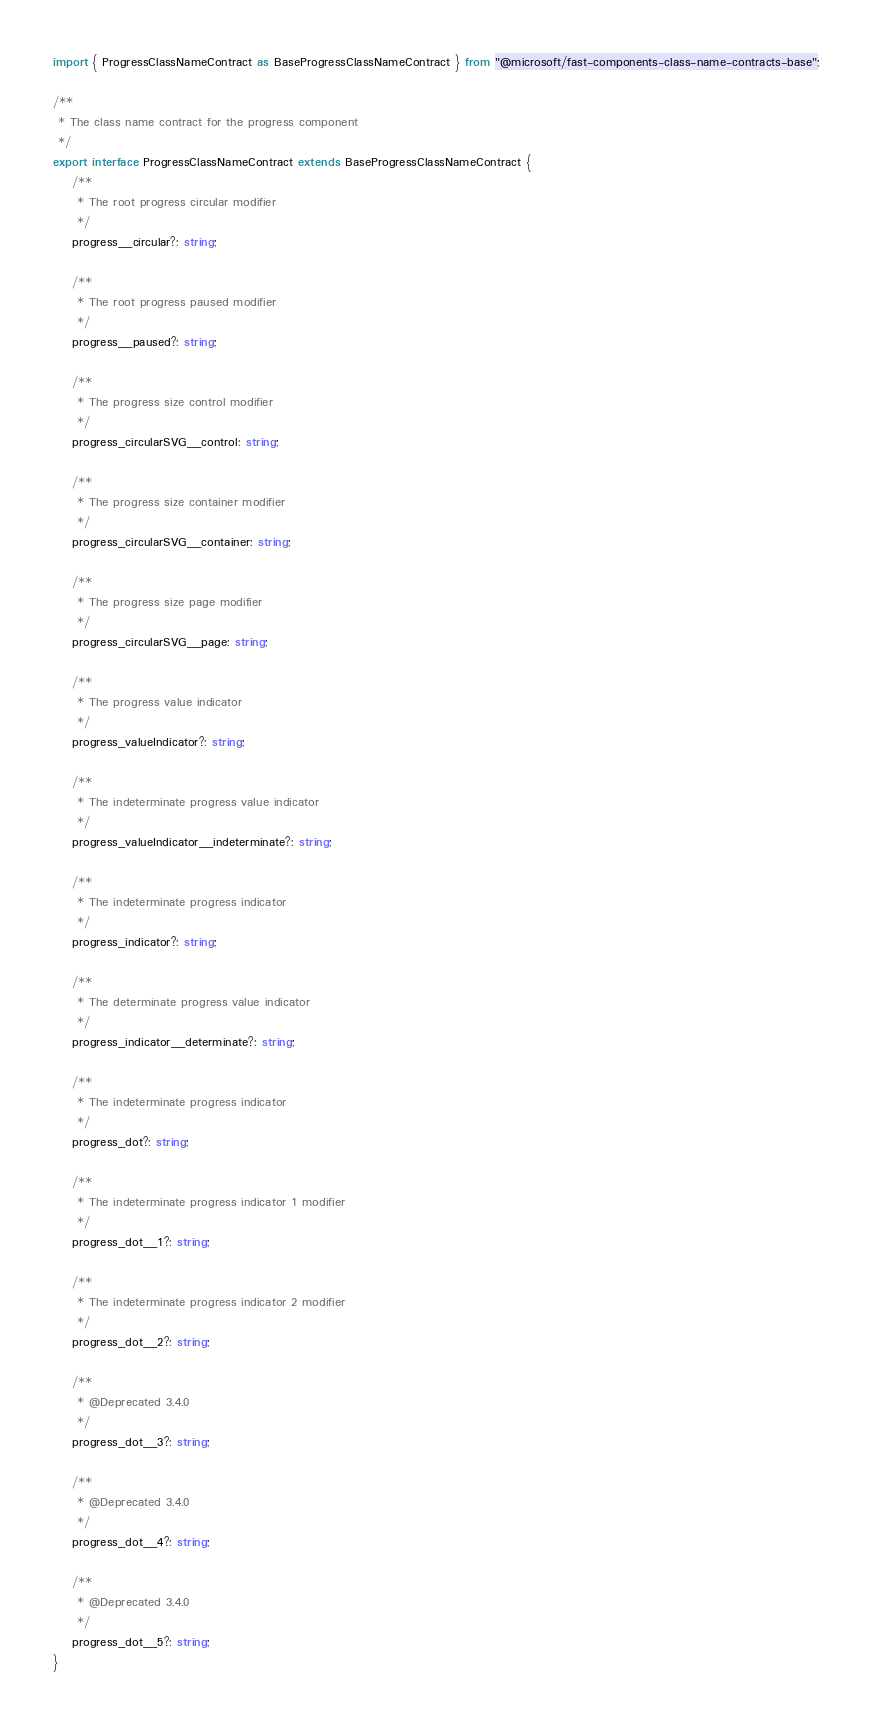<code> <loc_0><loc_0><loc_500><loc_500><_TypeScript_>import { ProgressClassNameContract as BaseProgressClassNameContract } from "@microsoft/fast-components-class-name-contracts-base";

/**
 * The class name contract for the progress component
 */
export interface ProgressClassNameContract extends BaseProgressClassNameContract {
    /**
     * The root progress circular modifier
     */
    progress__circular?: string;

    /**
     * The root progress paused modifier
     */
    progress__paused?: string;

    /**
     * The progress size control modifier
     */
    progress_circularSVG__control: string;

    /**
     * The progress size container modifier
     */
    progress_circularSVG__container: string;

    /**
     * The progress size page modifier
     */
    progress_circularSVG__page: string;

    /**
     * The progress value indicator
     */
    progress_valueIndicator?: string;

    /**
     * The indeterminate progress value indicator
     */
    progress_valueIndicator__indeterminate?: string;

    /**
     * The indeterminate progress indicator
     */
    progress_indicator?: string;

    /**
     * The determinate progress value indicator
     */
    progress_indicator__determinate?: string;

    /**
     * The indeterminate progress indicator
     */
    progress_dot?: string;

    /**
     * The indeterminate progress indicator 1 modifier
     */
    progress_dot__1?: string;

    /**
     * The indeterminate progress indicator 2 modifier
     */
    progress_dot__2?: string;

    /**
     * @Deprecated 3.4.0
     */
    progress_dot__3?: string;

    /**
     * @Deprecated 3.4.0
     */
    progress_dot__4?: string;

    /**
     * @Deprecated 3.4.0
     */
    progress_dot__5?: string;
}
</code> 